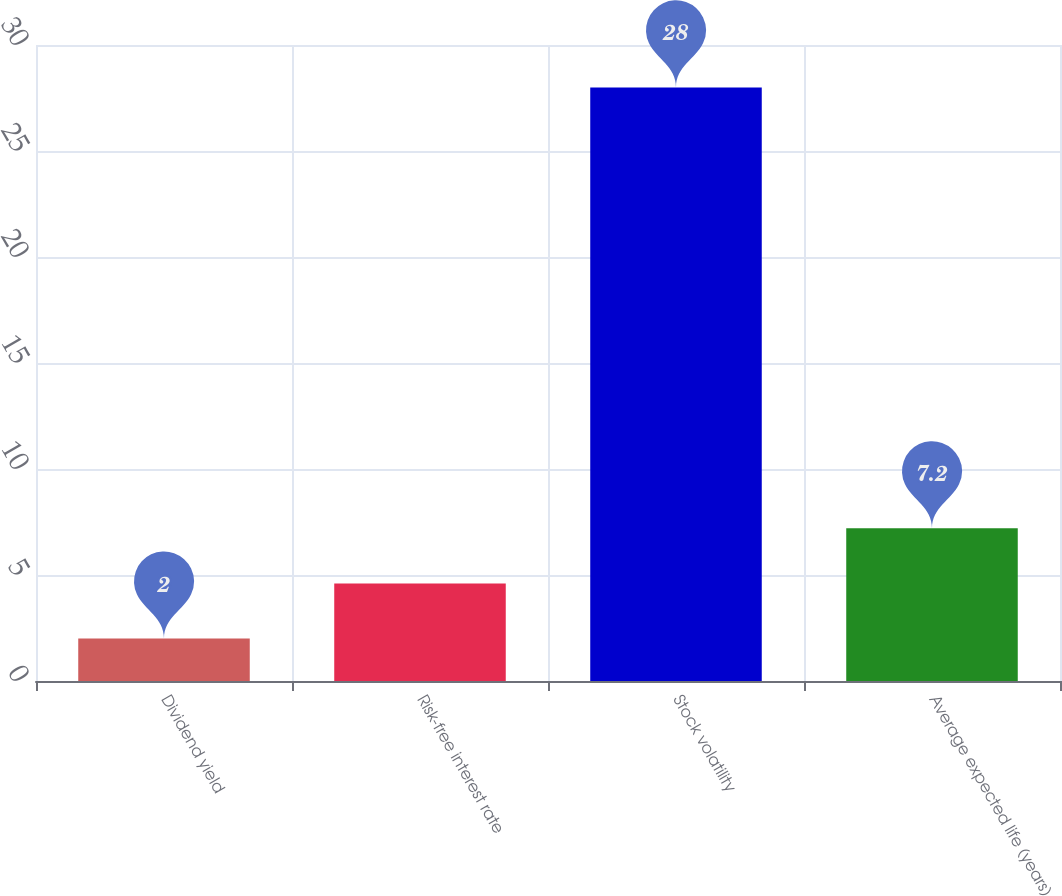Convert chart to OTSL. <chart><loc_0><loc_0><loc_500><loc_500><bar_chart><fcel>Dividend yield<fcel>Risk-free interest rate<fcel>Stock volatility<fcel>Average expected life (years)<nl><fcel>2<fcel>4.6<fcel>28<fcel>7.2<nl></chart> 